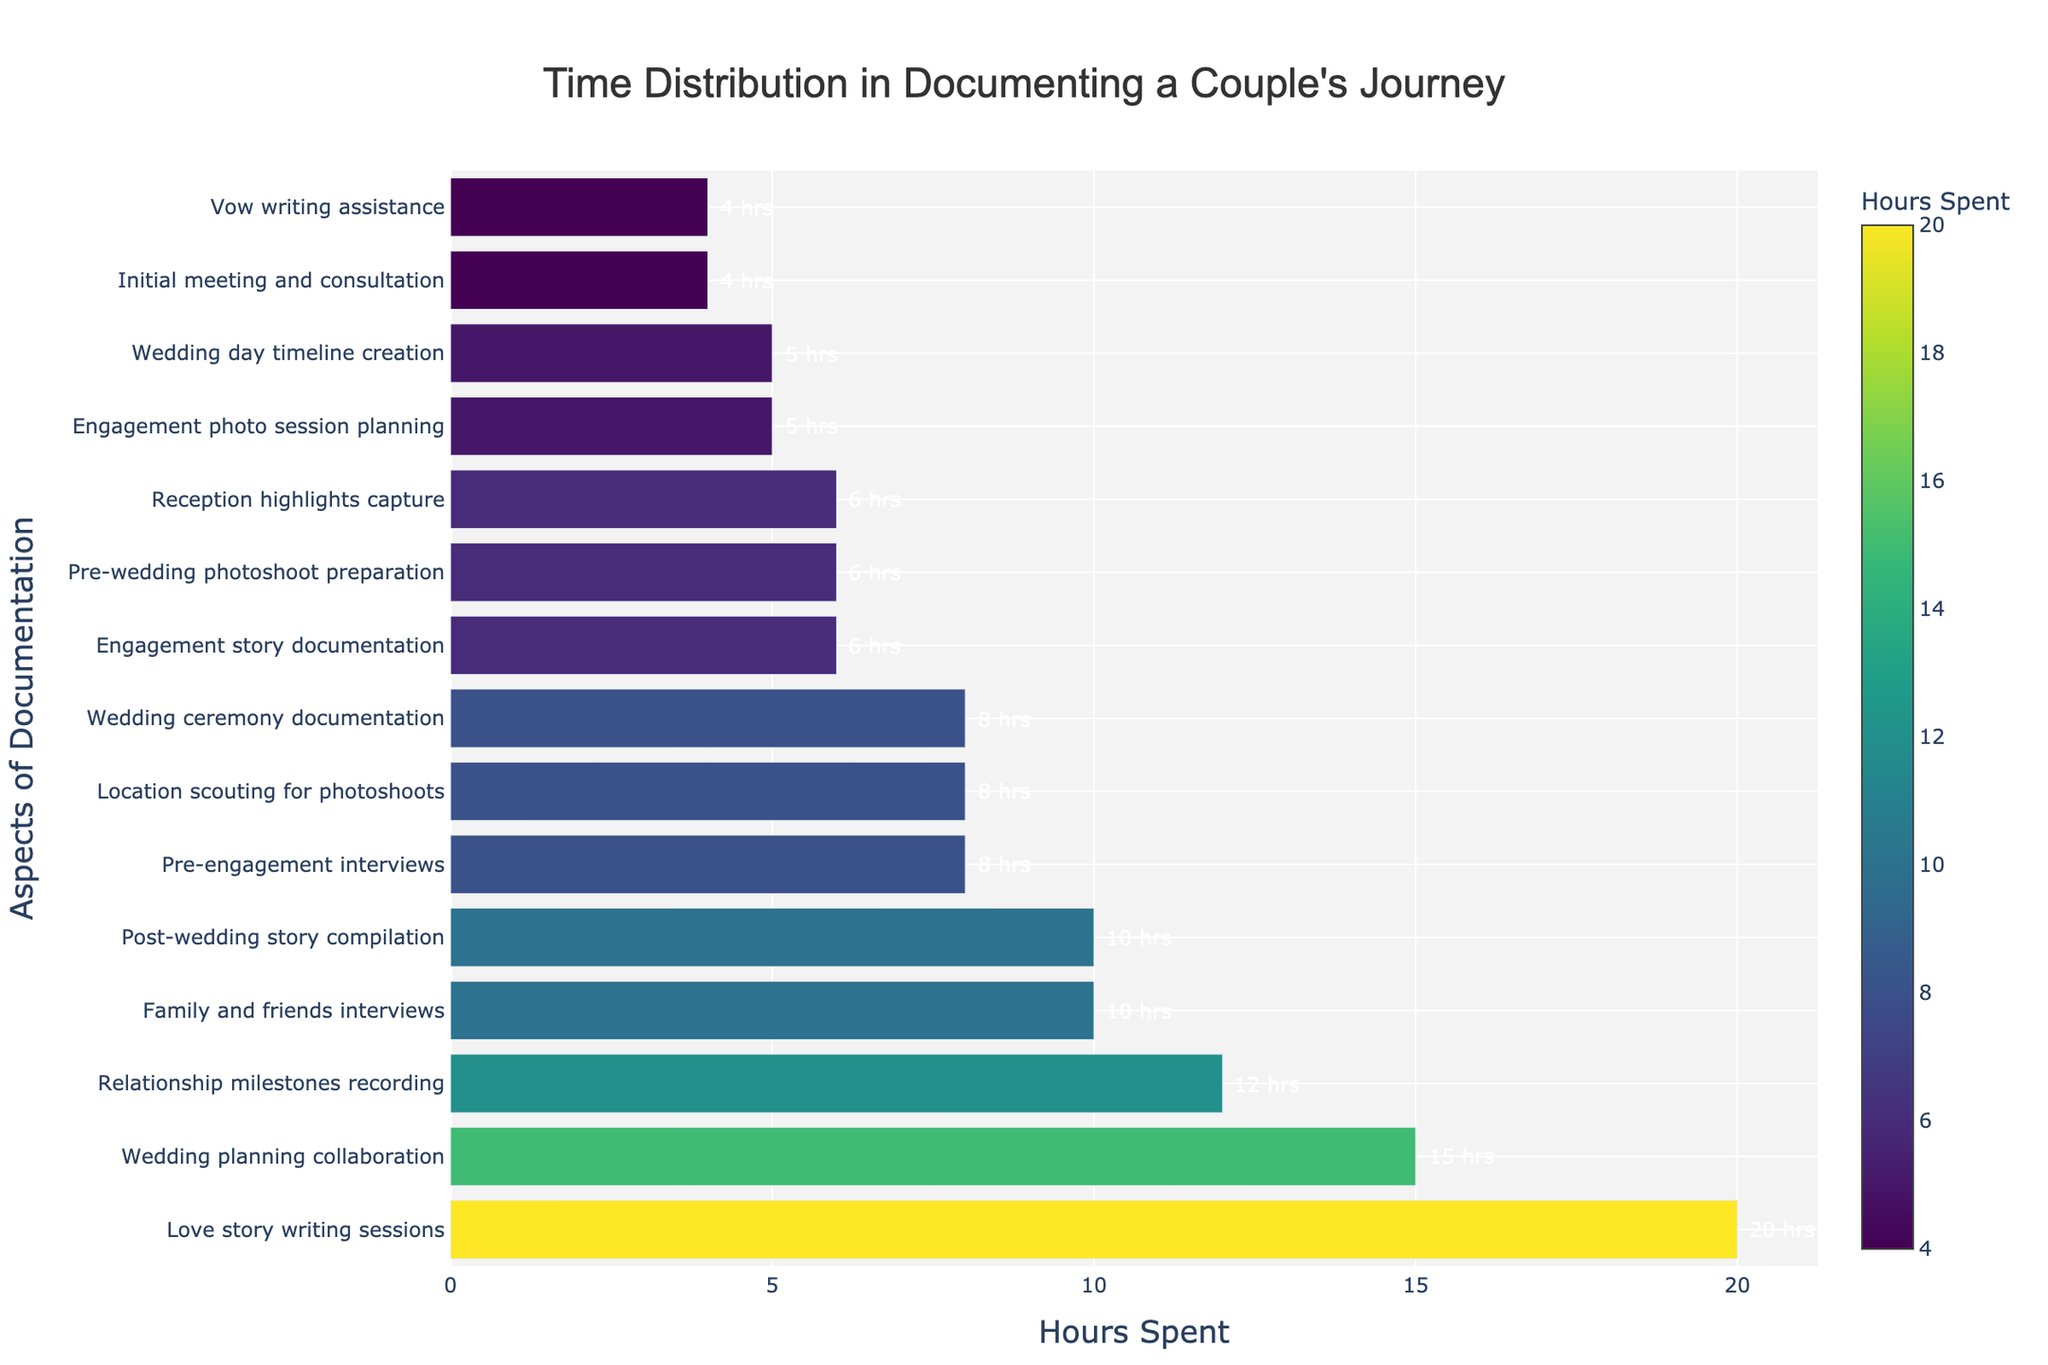What's the aspect with the highest hours spent? The bar chart displays 'Love story writing sessions' as having the tallest bar, indicating it has the highest hours spent.
Answer: Love story writing sessions Which aspect has the lowest hours spent, and how many hours were spent on it? The shortest bar represents 'Initial meeting and consultation' and 'Vow writing assistance,' both indicating the lowest hours spent.
Answer: 4 hrs What's the total time spent on 'Wedding planning collaboration' and 'Pre-wedding photoshoot preparation'? Add the hours for 'Wedding planning collaboration' (15 hrs) and 'Pre-wedding photoshoot preparation' (6 hrs): 15 + 6.
Answer: 21 hrs Which aspect required more time: 'Family and friends interviews' or 'Wedding ceremony documentation'? Compare the hours spent on each: 'Family and friends interviews' (10 hrs) and 'Wedding ceremony documentation' (8 hrs).
Answer: Family and friends interviews What are the median hours spent on the given aspects? To find the median, sort the hours and pick the middle value: [4, 4, 5, 5, 6, 6, 6, 8, 8, 8, 10, 10, 12, 15, 20]. The middle value is 8 (8th position).
Answer: 8 Is the time spent on 'Engagement story documentation' greater than the time spent on 'Reception highlights capture'? Compare the hours for each: 'Engagement story documentation' (6 hrs) and 'Reception highlights capture' (6 hrs).
Answer: Equal What is the average time spent on 'Pre-engagement interviews,' 'Engagement story documentation,' and 'Engagement photo session planning'? Add the hours for each and divide by the number of aspects: (8 + 6 + 5) / 3.
Answer: 6.33 hrs Identify the aspect with the second-highest time spent. The second tallest bar represents 'Wedding planning collaboration,' which indicates the second-highest hours spent (15 hrs).
Answer: Wedding planning collaboration How does the length of the bar for 'Location scouting for photoshoots' compare to 'Post-wedding story compilation'? The 'Location scouting for photoshoots' bar (8 hrs) is shorter than the 'Post-wedding story compilation' bar (10 hrs).
Answer: Shorter Which aspects have exactly 6 hours spent on documentation? Refer to the bars of length corresponding to 6 hours: 'Engagement story documentation,' 'Pre-wedding photoshoot preparation,' and 'Reception highlights capture.'
Answer: Engagement story documentation, Pre-wedding photoshoot preparation, Reception highlights capture 